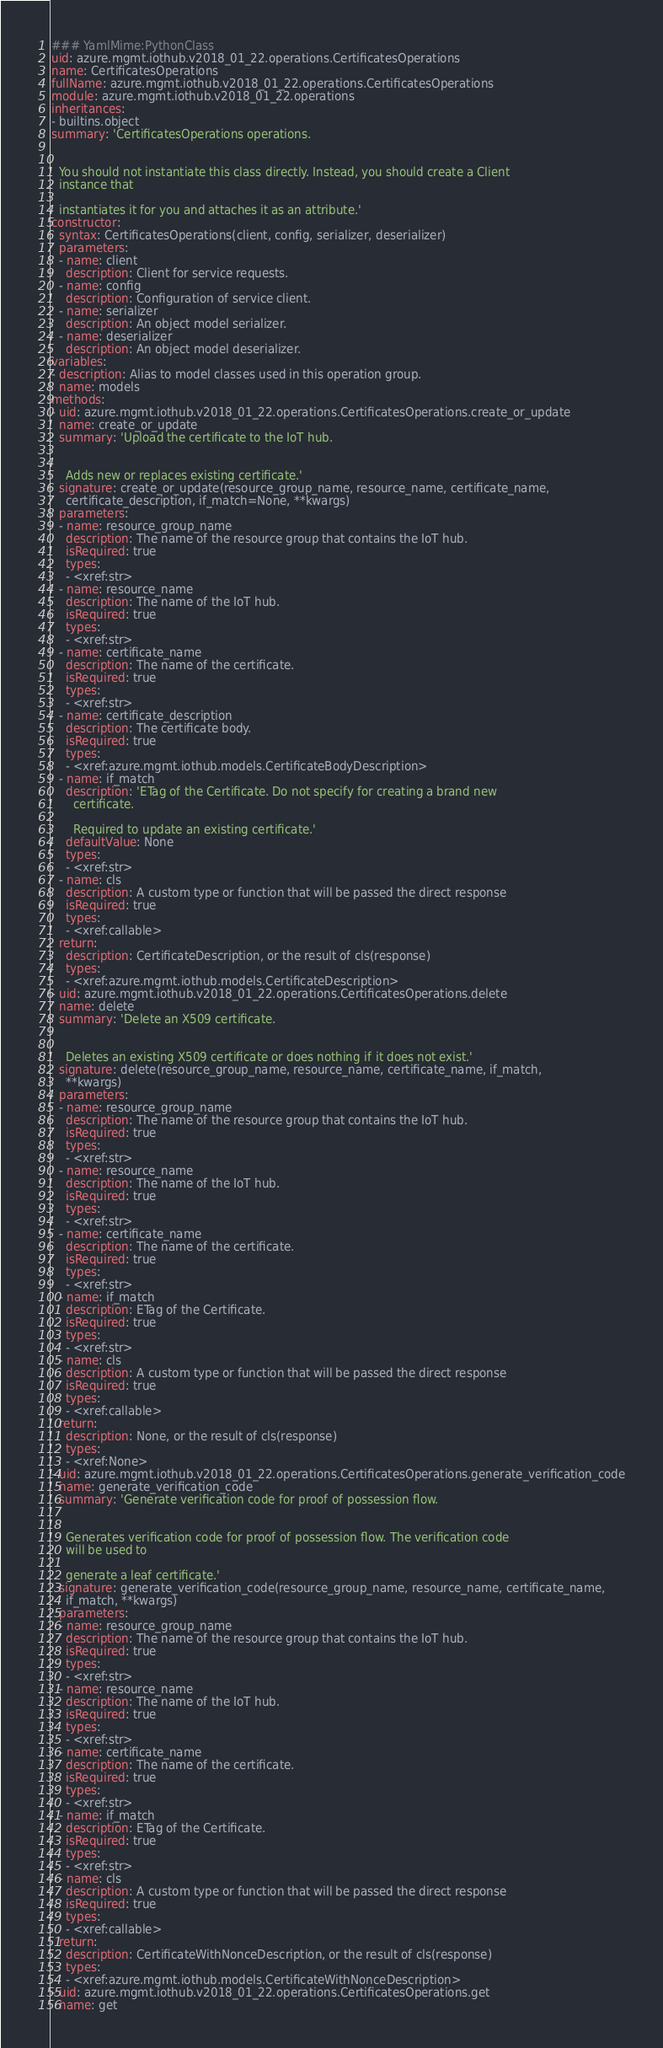<code> <loc_0><loc_0><loc_500><loc_500><_YAML_>### YamlMime:PythonClass
uid: azure.mgmt.iothub.v2018_01_22.operations.CertificatesOperations
name: CertificatesOperations
fullName: azure.mgmt.iothub.v2018_01_22.operations.CertificatesOperations
module: azure.mgmt.iothub.v2018_01_22.operations
inheritances:
- builtins.object
summary: 'CertificatesOperations operations.


  You should not instantiate this class directly. Instead, you should create a Client
  instance that

  instantiates it for you and attaches it as an attribute.'
constructor:
  syntax: CertificatesOperations(client, config, serializer, deserializer)
  parameters:
  - name: client
    description: Client for service requests.
  - name: config
    description: Configuration of service client.
  - name: serializer
    description: An object model serializer.
  - name: deserializer
    description: An object model deserializer.
variables:
- description: Alias to model classes used in this operation group.
  name: models
methods:
- uid: azure.mgmt.iothub.v2018_01_22.operations.CertificatesOperations.create_or_update
  name: create_or_update
  summary: 'Upload the certificate to the IoT hub.


    Adds new or replaces existing certificate.'
  signature: create_or_update(resource_group_name, resource_name, certificate_name,
    certificate_description, if_match=None, **kwargs)
  parameters:
  - name: resource_group_name
    description: The name of the resource group that contains the IoT hub.
    isRequired: true
    types:
    - <xref:str>
  - name: resource_name
    description: The name of the IoT hub.
    isRequired: true
    types:
    - <xref:str>
  - name: certificate_name
    description: The name of the certificate.
    isRequired: true
    types:
    - <xref:str>
  - name: certificate_description
    description: The certificate body.
    isRequired: true
    types:
    - <xref:azure.mgmt.iothub.models.CertificateBodyDescription>
  - name: if_match
    description: 'ETag of the Certificate. Do not specify for creating a brand new
      certificate.

      Required to update an existing certificate.'
    defaultValue: None
    types:
    - <xref:str>
  - name: cls
    description: A custom type or function that will be passed the direct response
    isRequired: true
    types:
    - <xref:callable>
  return:
    description: CertificateDescription, or the result of cls(response)
    types:
    - <xref:azure.mgmt.iothub.models.CertificateDescription>
- uid: azure.mgmt.iothub.v2018_01_22.operations.CertificatesOperations.delete
  name: delete
  summary: 'Delete an X509 certificate.


    Deletes an existing X509 certificate or does nothing if it does not exist.'
  signature: delete(resource_group_name, resource_name, certificate_name, if_match,
    **kwargs)
  parameters:
  - name: resource_group_name
    description: The name of the resource group that contains the IoT hub.
    isRequired: true
    types:
    - <xref:str>
  - name: resource_name
    description: The name of the IoT hub.
    isRequired: true
    types:
    - <xref:str>
  - name: certificate_name
    description: The name of the certificate.
    isRequired: true
    types:
    - <xref:str>
  - name: if_match
    description: ETag of the Certificate.
    isRequired: true
    types:
    - <xref:str>
  - name: cls
    description: A custom type or function that will be passed the direct response
    isRequired: true
    types:
    - <xref:callable>
  return:
    description: None, or the result of cls(response)
    types:
    - <xref:None>
- uid: azure.mgmt.iothub.v2018_01_22.operations.CertificatesOperations.generate_verification_code
  name: generate_verification_code
  summary: 'Generate verification code for proof of possession flow.


    Generates verification code for proof of possession flow. The verification code
    will be used to

    generate a leaf certificate.'
  signature: generate_verification_code(resource_group_name, resource_name, certificate_name,
    if_match, **kwargs)
  parameters:
  - name: resource_group_name
    description: The name of the resource group that contains the IoT hub.
    isRequired: true
    types:
    - <xref:str>
  - name: resource_name
    description: The name of the IoT hub.
    isRequired: true
    types:
    - <xref:str>
  - name: certificate_name
    description: The name of the certificate.
    isRequired: true
    types:
    - <xref:str>
  - name: if_match
    description: ETag of the Certificate.
    isRequired: true
    types:
    - <xref:str>
  - name: cls
    description: A custom type or function that will be passed the direct response
    isRequired: true
    types:
    - <xref:callable>
  return:
    description: CertificateWithNonceDescription, or the result of cls(response)
    types:
    - <xref:azure.mgmt.iothub.models.CertificateWithNonceDescription>
- uid: azure.mgmt.iothub.v2018_01_22.operations.CertificatesOperations.get
  name: get</code> 